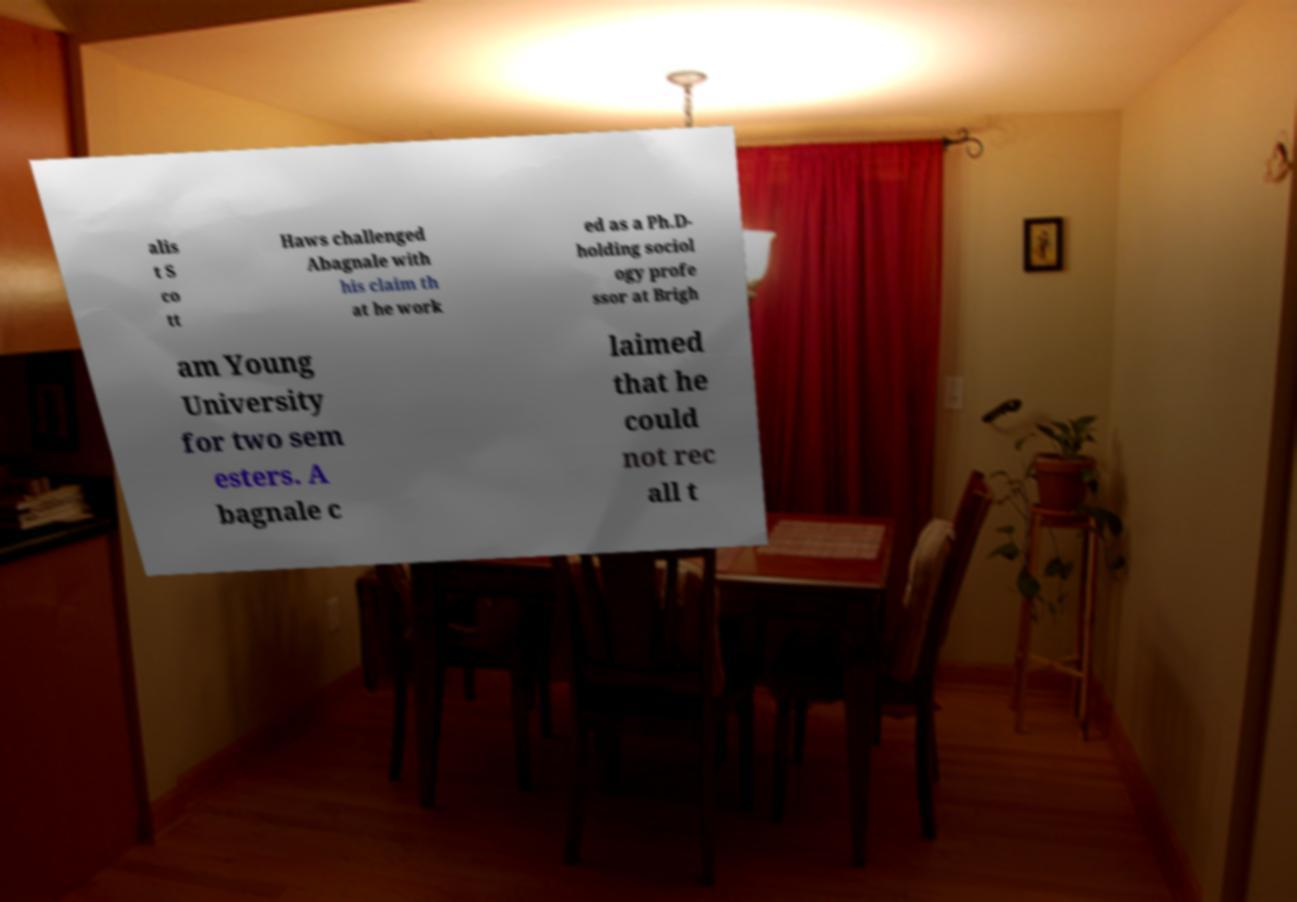I need the written content from this picture converted into text. Can you do that? alis t S co tt Haws challenged Abagnale with his claim th at he work ed as a Ph.D- holding sociol ogy profe ssor at Brigh am Young University for two sem esters. A bagnale c laimed that he could not rec all t 